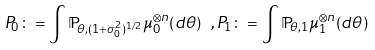Convert formula to latex. <formula><loc_0><loc_0><loc_500><loc_500>P _ { 0 } \colon = \int \mathbb { P } _ { \theta , ( 1 + \sigma _ { 0 } ^ { 2 } ) ^ { 1 / 2 } } \mu _ { 0 } ^ { \otimes n } ( d \theta ) \ , P _ { 1 } \colon = \int \mathbb { P } _ { \theta , 1 } \mu _ { 1 } ^ { \otimes n } ( d \theta )</formula> 